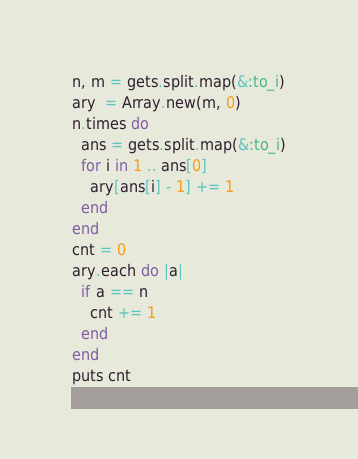Convert code to text. <code><loc_0><loc_0><loc_500><loc_500><_Ruby_>n, m = gets.split.map(&:to_i)
ary  = Array.new(m, 0)
n.times do
  ans = gets.split.map(&:to_i)
  for i in 1 .. ans[0]
    ary[ans[i] - 1] += 1
  end
end
cnt = 0
ary.each do |a|
  if a == n
    cnt += 1
  end
end
puts cnt
</code> 